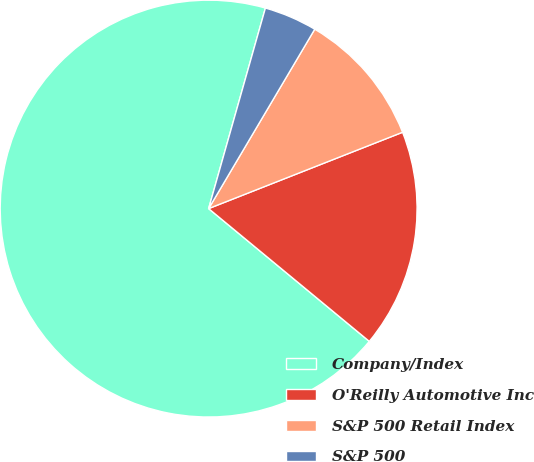Convert chart to OTSL. <chart><loc_0><loc_0><loc_500><loc_500><pie_chart><fcel>Company/Index<fcel>O'Reilly Automotive Inc<fcel>S&P 500 Retail Index<fcel>S&P 500<nl><fcel>68.4%<fcel>16.96%<fcel>10.53%<fcel>4.11%<nl></chart> 